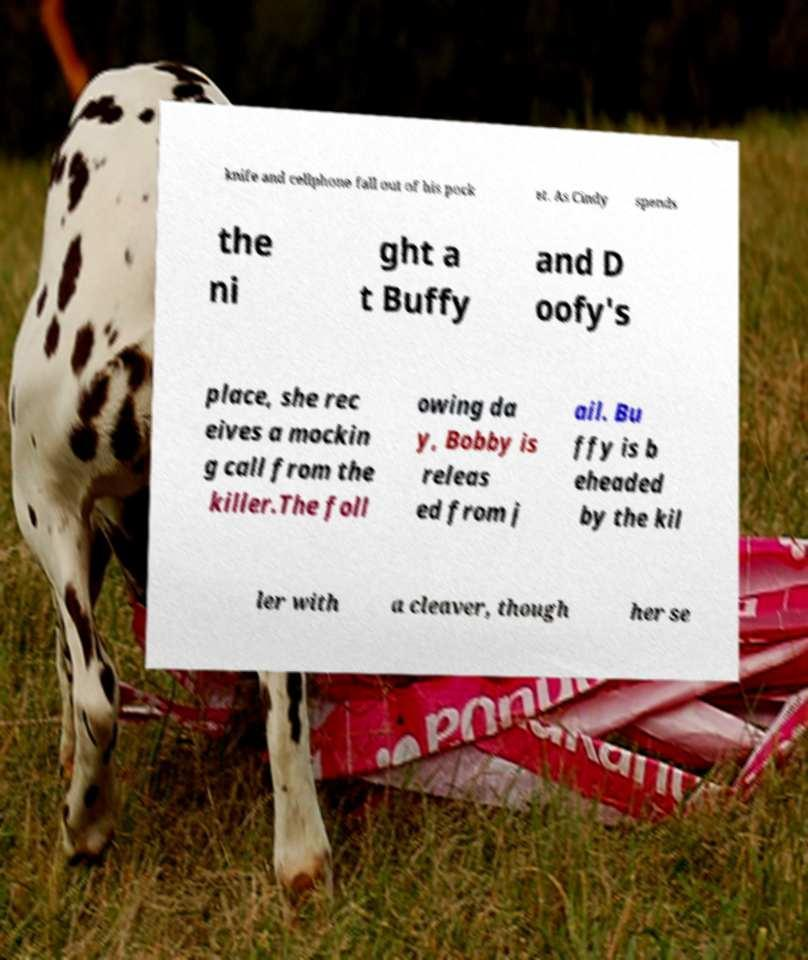For documentation purposes, I need the text within this image transcribed. Could you provide that? knife and cellphone fall out of his pock et. As Cindy spends the ni ght a t Buffy and D oofy's place, she rec eives a mockin g call from the killer.The foll owing da y, Bobby is releas ed from j ail. Bu ffy is b eheaded by the kil ler with a cleaver, though her se 